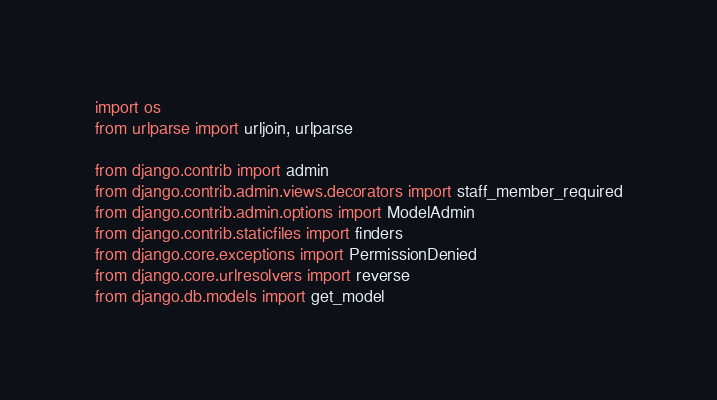Convert code to text. <code><loc_0><loc_0><loc_500><loc_500><_Python_>
import os
from urlparse import urljoin, urlparse

from django.contrib import admin
from django.contrib.admin.views.decorators import staff_member_required
from django.contrib.admin.options import ModelAdmin
from django.contrib.staticfiles import finders
from django.core.exceptions import PermissionDenied
from django.core.urlresolvers import reverse
from django.db.models import get_model</code> 